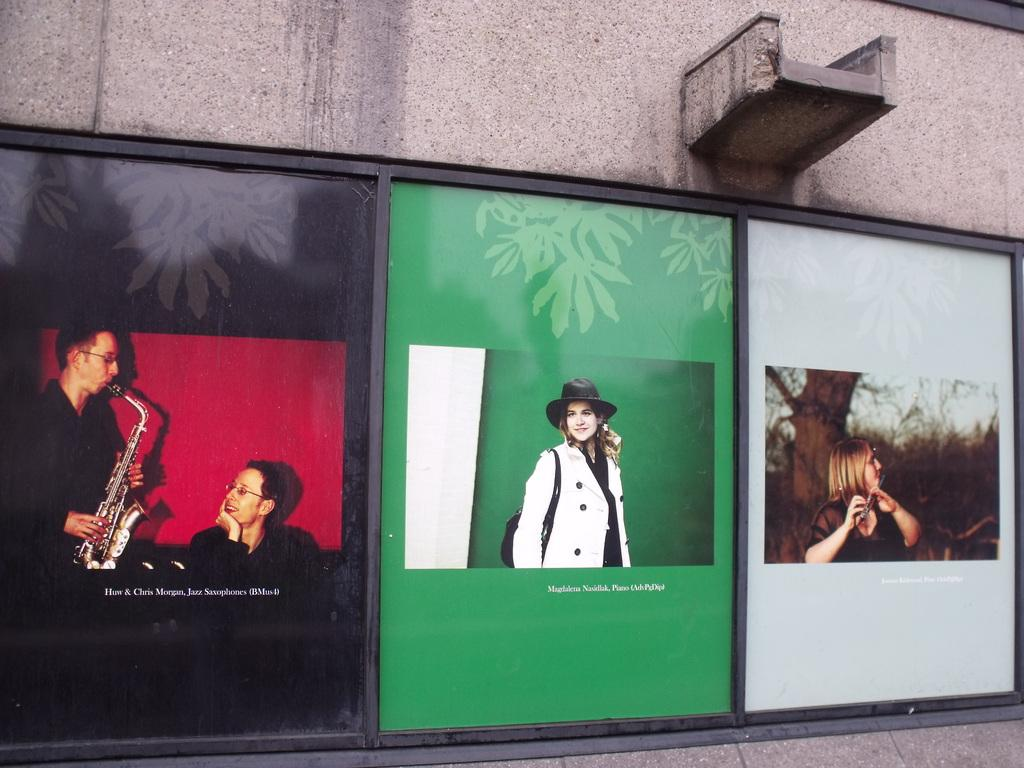What is the main object in the image? There is a billboard in the image. What can be seen on the billboard? The billboard has pictures and text on it. Where is the billboard located? The billboard is on a wall. How does the muscle on the billboard increase in size? There is no muscle present on the billboard; it only has pictures and text. 